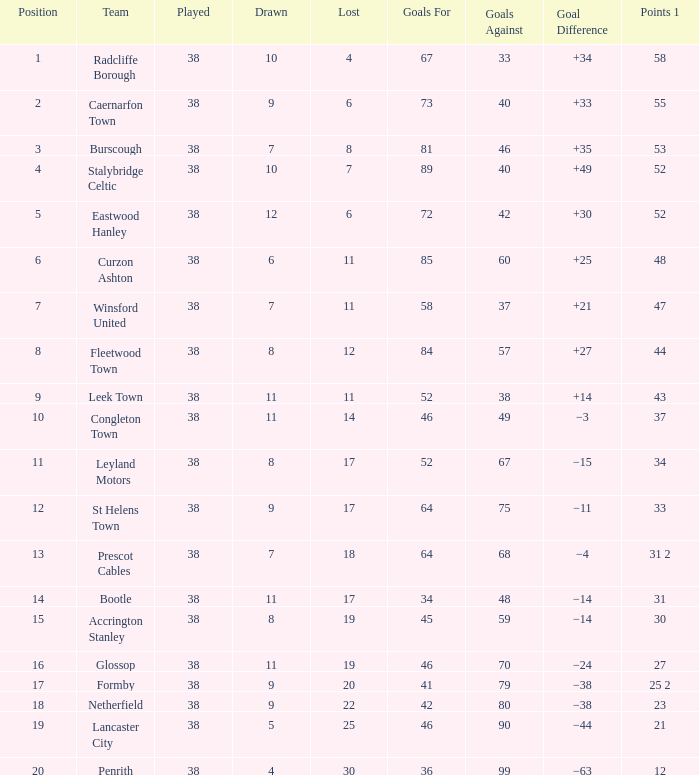What aims against had a goal in favor of 46, and took part in less than 38? None. 